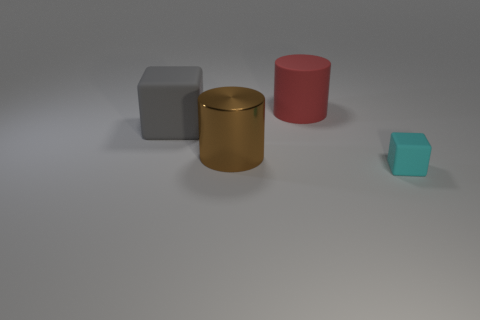How many green objects are there?
Ensure brevity in your answer.  0. How many red things are large cubes or cylinders?
Ensure brevity in your answer.  1. Do the large cylinder behind the big rubber block and the tiny cyan cube have the same material?
Offer a terse response. Yes. How many other objects are there of the same material as the large gray cube?
Your answer should be very brief. 2. What material is the red object?
Ensure brevity in your answer.  Rubber. What size is the matte object left of the red thing?
Ensure brevity in your answer.  Large. How many big red matte cylinders are left of the big cylinder in front of the big gray object?
Your answer should be very brief. 0. Is the shape of the big red object right of the gray matte cube the same as the large object that is in front of the big rubber block?
Give a very brief answer. Yes. What number of objects are both behind the brown thing and on the right side of the big gray rubber cube?
Ensure brevity in your answer.  1. There is a gray thing that is the same size as the brown shiny cylinder; what is its shape?
Give a very brief answer. Cube. 